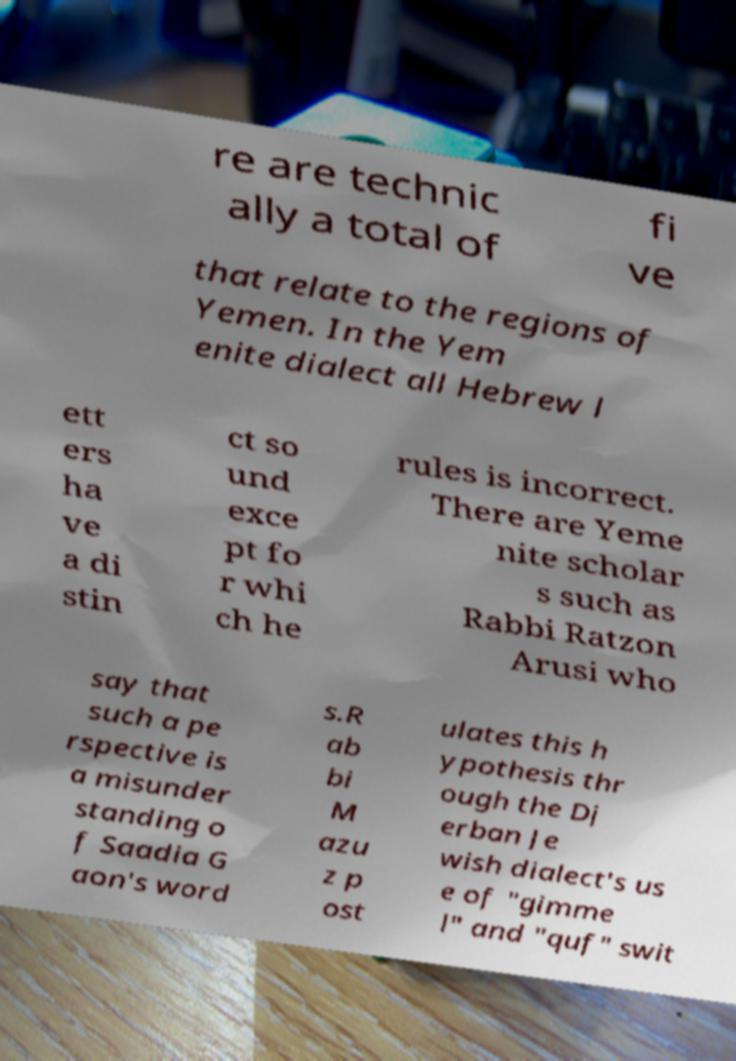Please read and relay the text visible in this image. What does it say? re are technic ally a total of fi ve that relate to the regions of Yemen. In the Yem enite dialect all Hebrew l ett ers ha ve a di stin ct so und exce pt fo r whi ch he rules is incorrect. There are Yeme nite scholar s such as Rabbi Ratzon Arusi who say that such a pe rspective is a misunder standing o f Saadia G aon's word s.R ab bi M azu z p ost ulates this h ypothesis thr ough the Dj erban Je wish dialect's us e of "gimme l" and "quf" swit 